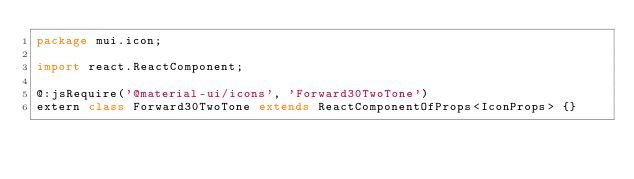Convert code to text. <code><loc_0><loc_0><loc_500><loc_500><_Haxe_>package mui.icon;

import react.ReactComponent;

@:jsRequire('@material-ui/icons', 'Forward30TwoTone')
extern class Forward30TwoTone extends ReactComponentOfProps<IconProps> {}
</code> 